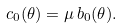Convert formula to latex. <formula><loc_0><loc_0><loc_500><loc_500>c _ { 0 } ( \theta ) = \mu \, b _ { 0 } ( \theta ) .</formula> 